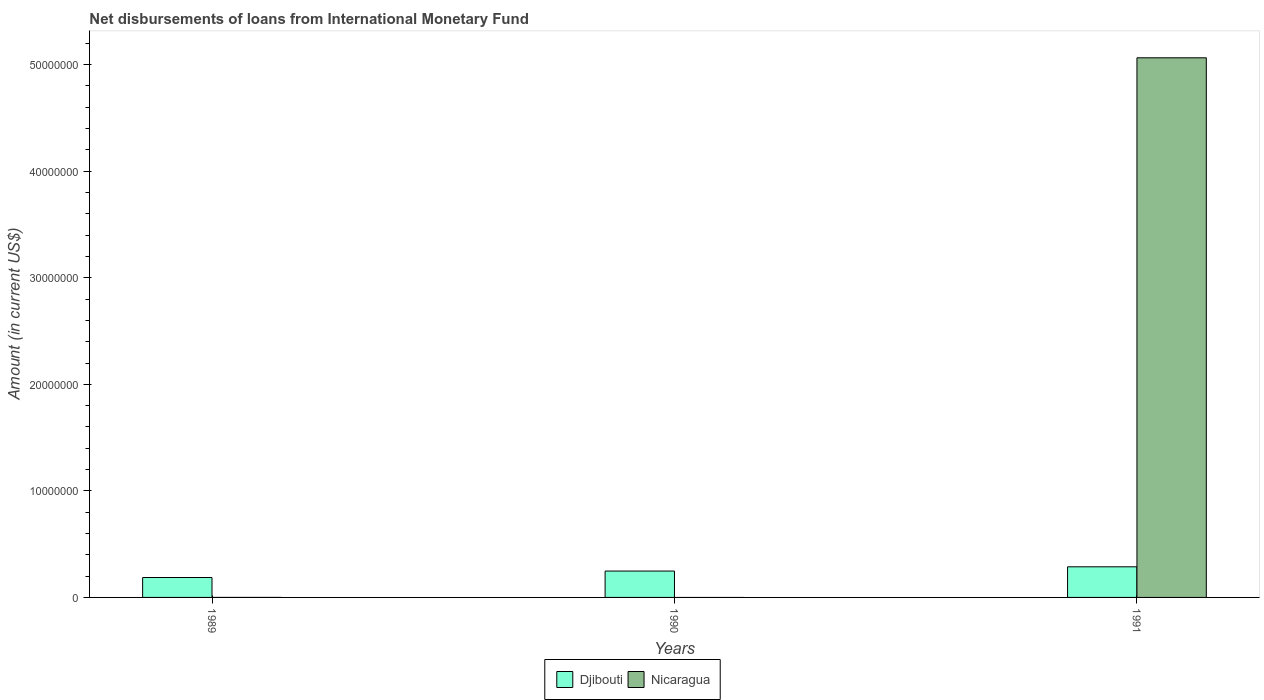Are the number of bars per tick equal to the number of legend labels?
Provide a succinct answer. No. Are the number of bars on each tick of the X-axis equal?
Keep it short and to the point. No. How many bars are there on the 1st tick from the left?
Your response must be concise. 1. In how many cases, is the number of bars for a given year not equal to the number of legend labels?
Ensure brevity in your answer.  2. What is the amount of loans disbursed in Djibouti in 1990?
Ensure brevity in your answer.  2.48e+06. Across all years, what is the maximum amount of loans disbursed in Nicaragua?
Offer a very short reply. 5.06e+07. Across all years, what is the minimum amount of loans disbursed in Nicaragua?
Your response must be concise. 0. In which year was the amount of loans disbursed in Nicaragua maximum?
Give a very brief answer. 1991. What is the total amount of loans disbursed in Nicaragua in the graph?
Give a very brief answer. 5.06e+07. What is the difference between the amount of loans disbursed in Djibouti in 1990 and that in 1991?
Provide a succinct answer. -3.99e+05. What is the difference between the amount of loans disbursed in Djibouti in 1989 and the amount of loans disbursed in Nicaragua in 1990?
Give a very brief answer. 1.87e+06. What is the average amount of loans disbursed in Djibouti per year?
Keep it short and to the point. 2.41e+06. In the year 1991, what is the difference between the amount of loans disbursed in Djibouti and amount of loans disbursed in Nicaragua?
Make the answer very short. -4.78e+07. In how many years, is the amount of loans disbursed in Djibouti greater than 20000000 US$?
Give a very brief answer. 0. What is the difference between the highest and the second highest amount of loans disbursed in Djibouti?
Provide a short and direct response. 3.99e+05. What is the difference between the highest and the lowest amount of loans disbursed in Nicaragua?
Your response must be concise. 5.06e+07. In how many years, is the amount of loans disbursed in Djibouti greater than the average amount of loans disbursed in Djibouti taken over all years?
Offer a very short reply. 2. Is the sum of the amount of loans disbursed in Djibouti in 1989 and 1991 greater than the maximum amount of loans disbursed in Nicaragua across all years?
Make the answer very short. No. How many bars are there?
Provide a short and direct response. 4. What is the difference between two consecutive major ticks on the Y-axis?
Give a very brief answer. 1.00e+07. Where does the legend appear in the graph?
Make the answer very short. Bottom center. How many legend labels are there?
Your answer should be very brief. 2. How are the legend labels stacked?
Provide a short and direct response. Horizontal. What is the title of the graph?
Make the answer very short. Net disbursements of loans from International Monetary Fund. What is the label or title of the Y-axis?
Make the answer very short. Amount (in current US$). What is the Amount (in current US$) in Djibouti in 1989?
Your answer should be very brief. 1.87e+06. What is the Amount (in current US$) of Nicaragua in 1989?
Provide a short and direct response. 0. What is the Amount (in current US$) of Djibouti in 1990?
Your response must be concise. 2.48e+06. What is the Amount (in current US$) of Nicaragua in 1990?
Offer a terse response. 0. What is the Amount (in current US$) in Djibouti in 1991?
Your answer should be compact. 2.87e+06. What is the Amount (in current US$) in Nicaragua in 1991?
Your answer should be compact. 5.06e+07. Across all years, what is the maximum Amount (in current US$) of Djibouti?
Offer a terse response. 2.87e+06. Across all years, what is the maximum Amount (in current US$) in Nicaragua?
Provide a succinct answer. 5.06e+07. Across all years, what is the minimum Amount (in current US$) in Djibouti?
Your answer should be very brief. 1.87e+06. What is the total Amount (in current US$) in Djibouti in the graph?
Offer a very short reply. 7.22e+06. What is the total Amount (in current US$) in Nicaragua in the graph?
Keep it short and to the point. 5.06e+07. What is the difference between the Amount (in current US$) of Djibouti in 1989 and that in 1990?
Your response must be concise. -6.05e+05. What is the difference between the Amount (in current US$) of Djibouti in 1989 and that in 1991?
Your response must be concise. -1.00e+06. What is the difference between the Amount (in current US$) of Djibouti in 1990 and that in 1991?
Offer a very short reply. -3.99e+05. What is the difference between the Amount (in current US$) in Djibouti in 1989 and the Amount (in current US$) in Nicaragua in 1991?
Keep it short and to the point. -4.88e+07. What is the difference between the Amount (in current US$) of Djibouti in 1990 and the Amount (in current US$) of Nicaragua in 1991?
Keep it short and to the point. -4.82e+07. What is the average Amount (in current US$) of Djibouti per year?
Your response must be concise. 2.41e+06. What is the average Amount (in current US$) of Nicaragua per year?
Your answer should be very brief. 1.69e+07. In the year 1991, what is the difference between the Amount (in current US$) in Djibouti and Amount (in current US$) in Nicaragua?
Offer a very short reply. -4.78e+07. What is the ratio of the Amount (in current US$) of Djibouti in 1989 to that in 1990?
Make the answer very short. 0.76. What is the ratio of the Amount (in current US$) in Djibouti in 1989 to that in 1991?
Give a very brief answer. 0.65. What is the ratio of the Amount (in current US$) of Djibouti in 1990 to that in 1991?
Offer a terse response. 0.86. What is the difference between the highest and the second highest Amount (in current US$) in Djibouti?
Your response must be concise. 3.99e+05. What is the difference between the highest and the lowest Amount (in current US$) in Djibouti?
Offer a terse response. 1.00e+06. What is the difference between the highest and the lowest Amount (in current US$) in Nicaragua?
Your answer should be compact. 5.06e+07. 